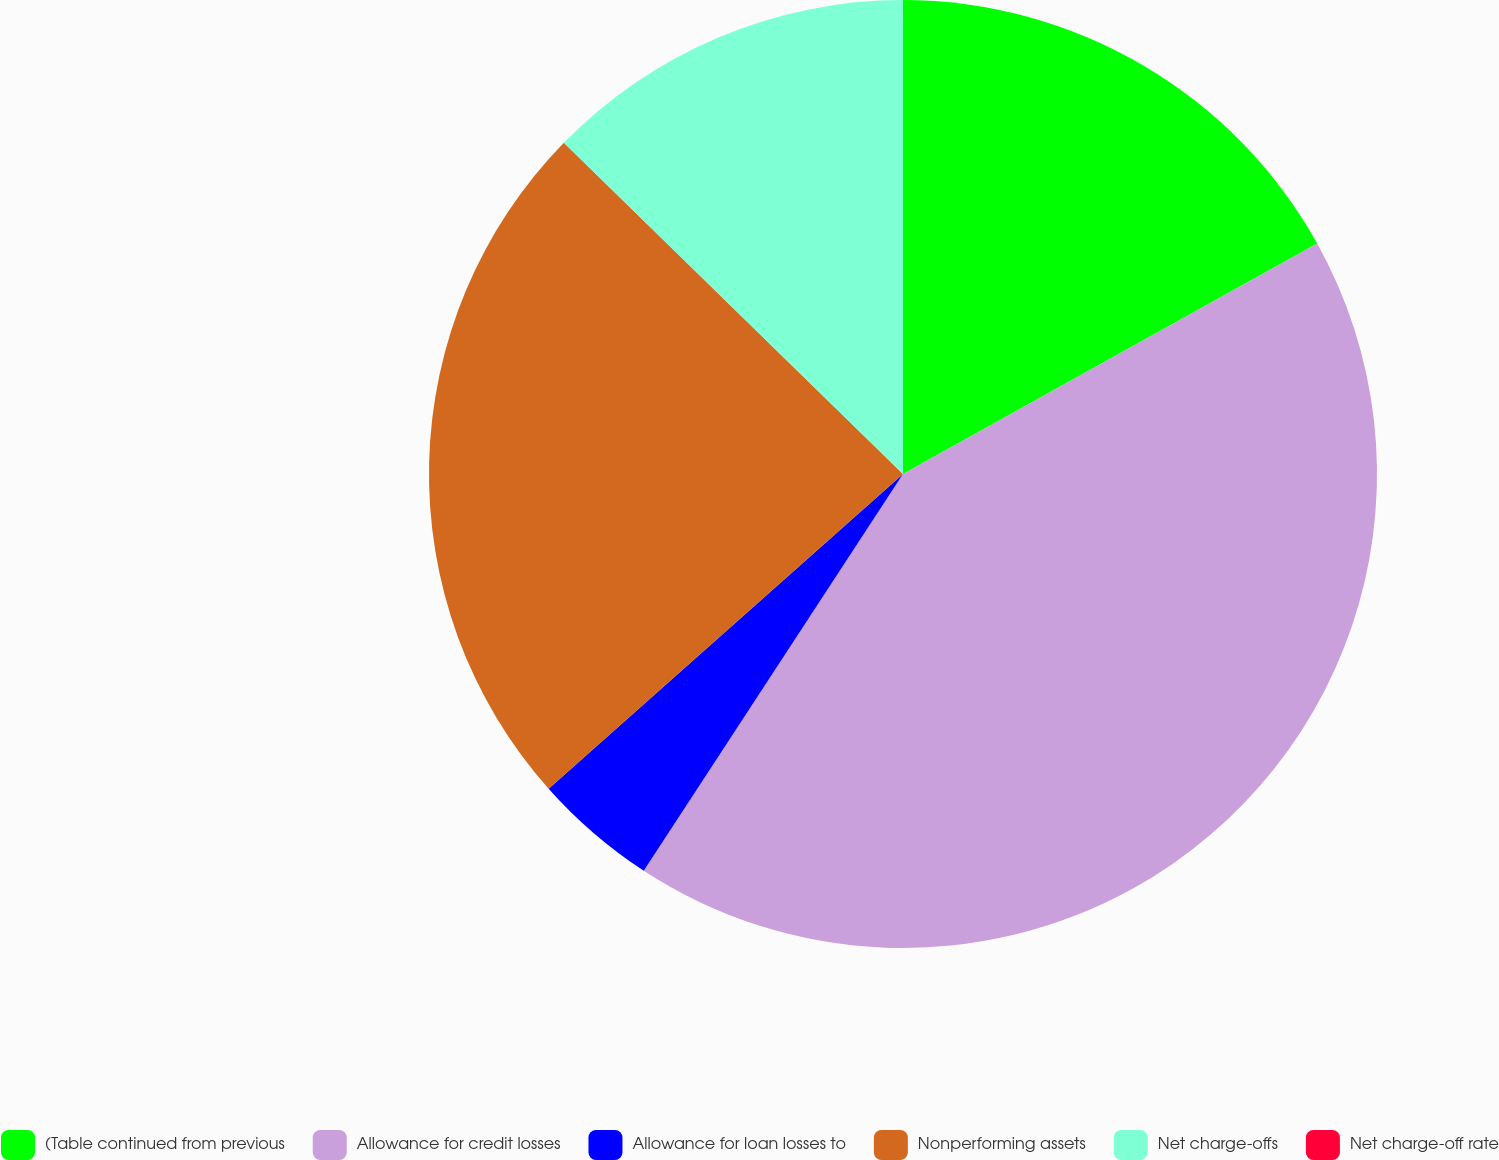<chart> <loc_0><loc_0><loc_500><loc_500><pie_chart><fcel>(Table continued from previous<fcel>Allowance for credit losses<fcel>Allowance for loan losses to<fcel>Nonperforming assets<fcel>Net charge-offs<fcel>Net charge-off rate<nl><fcel>16.92%<fcel>42.29%<fcel>4.23%<fcel>23.87%<fcel>12.69%<fcel>0.0%<nl></chart> 